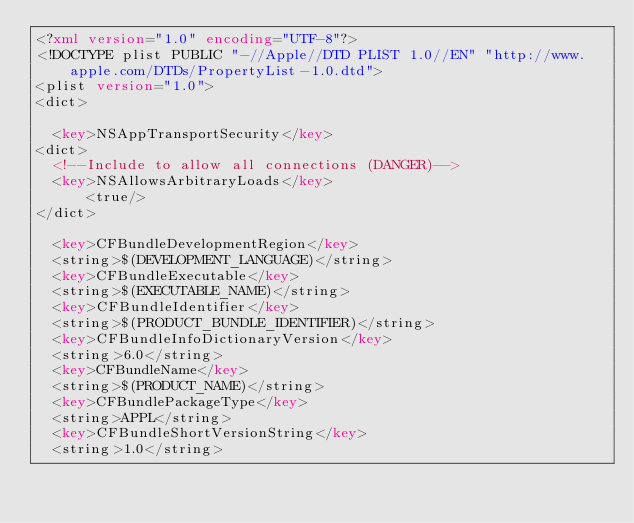<code> <loc_0><loc_0><loc_500><loc_500><_XML_><?xml version="1.0" encoding="UTF-8"?>
<!DOCTYPE plist PUBLIC "-//Apple//DTD PLIST 1.0//EN" "http://www.apple.com/DTDs/PropertyList-1.0.dtd">
<plist version="1.0">
<dict>
	
	<key>NSAppTransportSecurity</key>
<dict>
  <!--Include to allow all connections (DANGER)-->
  <key>NSAllowsArbitraryLoads</key>
      <true/>
</dict>

	<key>CFBundleDevelopmentRegion</key>
	<string>$(DEVELOPMENT_LANGUAGE)</string>
	<key>CFBundleExecutable</key>
	<string>$(EXECUTABLE_NAME)</string>
	<key>CFBundleIdentifier</key>
	<string>$(PRODUCT_BUNDLE_IDENTIFIER)</string>
	<key>CFBundleInfoDictionaryVersion</key>
	<string>6.0</string>
	<key>CFBundleName</key>
	<string>$(PRODUCT_NAME)</string>
	<key>CFBundlePackageType</key>
	<string>APPL</string>
	<key>CFBundleShortVersionString</key>
	<string>1.0</string></code> 